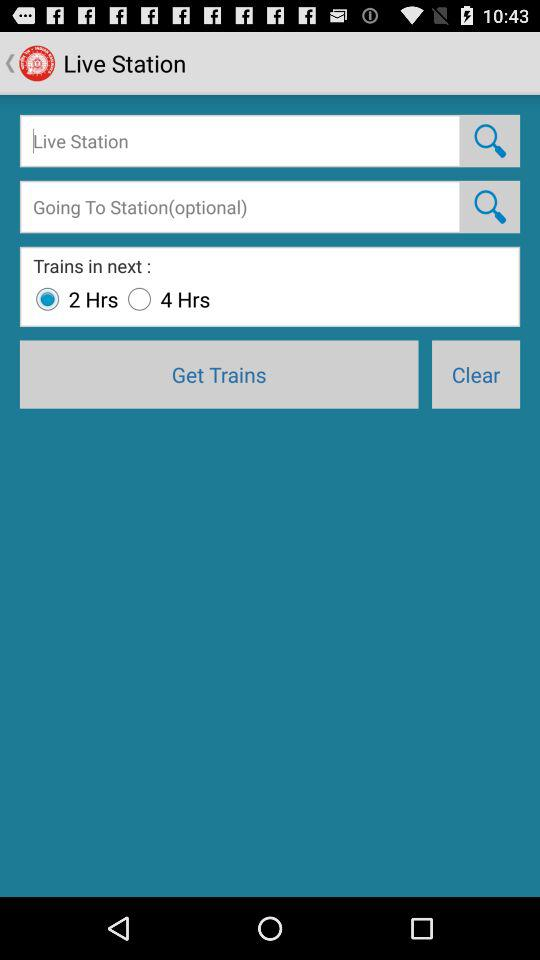What is the selected duration? The selected duration is 2 hours. 